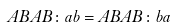<formula> <loc_0><loc_0><loc_500><loc_500>A B A B \colon a b = A B A B \colon b a</formula> 